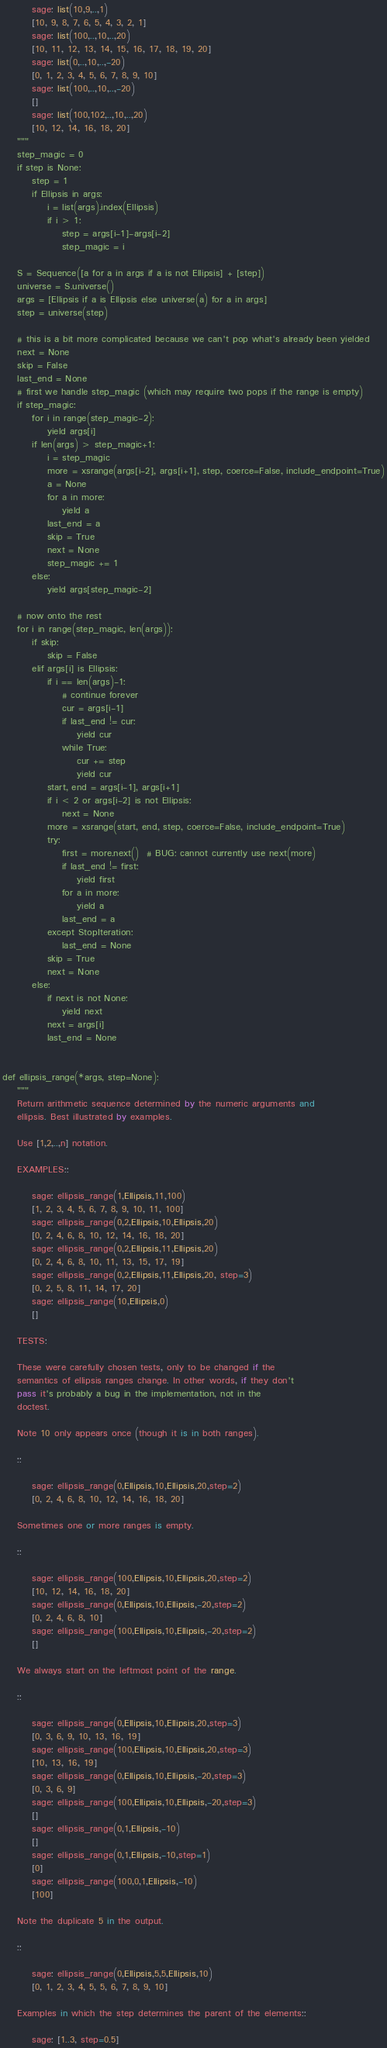Convert code to text. <code><loc_0><loc_0><loc_500><loc_500><_Cython_>        sage: list(10,9,..,1)
        [10, 9, 8, 7, 6, 5, 4, 3, 2, 1]
        sage: list(100,..,10,..,20)
        [10, 11, 12, 13, 14, 15, 16, 17, 18, 19, 20]
        sage: list(0,..,10,..,-20)
        [0, 1, 2, 3, 4, 5, 6, 7, 8, 9, 10]
        sage: list(100,..,10,..,-20)
        []
        sage: list(100,102,..,10,..,20)
        [10, 12, 14, 16, 18, 20]
    """
    step_magic = 0
    if step is None:
        step = 1
        if Ellipsis in args:
            i = list(args).index(Ellipsis)
            if i > 1:
                step = args[i-1]-args[i-2]
                step_magic = i

    S = Sequence([a for a in args if a is not Ellipsis] + [step])
    universe = S.universe()
    args = [Ellipsis if a is Ellipsis else universe(a) for a in args]
    step = universe(step)

    # this is a bit more complicated because we can't pop what's already been yielded
    next = None
    skip = False
    last_end = None
    # first we handle step_magic (which may require two pops if the range is empty)
    if step_magic:
        for i in range(step_magic-2):
            yield args[i]
        if len(args) > step_magic+1:
            i = step_magic
            more = xsrange(args[i-2], args[i+1], step, coerce=False, include_endpoint=True)
            a = None
            for a in more:
                yield a
            last_end = a
            skip = True
            next = None
            step_magic += 1
        else:
            yield args[step_magic-2]

    # now onto the rest
    for i in range(step_magic, len(args)):
        if skip:
            skip = False
        elif args[i] is Ellipsis:
            if i == len(args)-1:
                # continue forever
                cur = args[i-1]
                if last_end != cur:
                    yield cur
                while True:
                    cur += step
                    yield cur
            start, end = args[i-1], args[i+1]
            if i < 2 or args[i-2] is not Ellipsis:
                next = None
            more = xsrange(start, end, step, coerce=False, include_endpoint=True)
            try:
                first = more.next()  # BUG: cannot currently use next(more)
                if last_end != first:
                    yield first
                for a in more:
                    yield a
                last_end = a
            except StopIteration:
                last_end = None
            skip = True
            next = None
        else:
            if next is not None:
                yield next
            next = args[i]
            last_end = None


def ellipsis_range(*args, step=None):
    """
    Return arithmetic sequence determined by the numeric arguments and
    ellipsis. Best illustrated by examples.

    Use [1,2,..,n] notation.

    EXAMPLES::

        sage: ellipsis_range(1,Ellipsis,11,100)
        [1, 2, 3, 4, 5, 6, 7, 8, 9, 10, 11, 100]
        sage: ellipsis_range(0,2,Ellipsis,10,Ellipsis,20)
        [0, 2, 4, 6, 8, 10, 12, 14, 16, 18, 20]
        sage: ellipsis_range(0,2,Ellipsis,11,Ellipsis,20)
        [0, 2, 4, 6, 8, 10, 11, 13, 15, 17, 19]
        sage: ellipsis_range(0,2,Ellipsis,11,Ellipsis,20, step=3)
        [0, 2, 5, 8, 11, 14, 17, 20]
        sage: ellipsis_range(10,Ellipsis,0)
        []

    TESTS:

    These were carefully chosen tests, only to be changed if the
    semantics of ellipsis ranges change. In other words, if they don't
    pass it's probably a bug in the implementation, not in the
    doctest.

    Note 10 only appears once (though it is in both ranges).

    ::

        sage: ellipsis_range(0,Ellipsis,10,Ellipsis,20,step=2)
        [0, 2, 4, 6, 8, 10, 12, 14, 16, 18, 20]

    Sometimes one or more ranges is empty.

    ::

        sage: ellipsis_range(100,Ellipsis,10,Ellipsis,20,step=2)
        [10, 12, 14, 16, 18, 20]
        sage: ellipsis_range(0,Ellipsis,10,Ellipsis,-20,step=2)
        [0, 2, 4, 6, 8, 10]
        sage: ellipsis_range(100,Ellipsis,10,Ellipsis,-20,step=2)
        []

    We always start on the leftmost point of the range.

    ::

        sage: ellipsis_range(0,Ellipsis,10,Ellipsis,20,step=3)
        [0, 3, 6, 9, 10, 13, 16, 19]
        sage: ellipsis_range(100,Ellipsis,10,Ellipsis,20,step=3)
        [10, 13, 16, 19]
        sage: ellipsis_range(0,Ellipsis,10,Ellipsis,-20,step=3)
        [0, 3, 6, 9]
        sage: ellipsis_range(100,Ellipsis,10,Ellipsis,-20,step=3)
        []
        sage: ellipsis_range(0,1,Ellipsis,-10)
        []
        sage: ellipsis_range(0,1,Ellipsis,-10,step=1)
        [0]
        sage: ellipsis_range(100,0,1,Ellipsis,-10)
        [100]

    Note the duplicate 5 in the output.

    ::

        sage: ellipsis_range(0,Ellipsis,5,5,Ellipsis,10)
        [0, 1, 2, 3, 4, 5, 5, 6, 7, 8, 9, 10]

    Examples in which the step determines the parent of the elements::

        sage: [1..3, step=0.5]</code> 